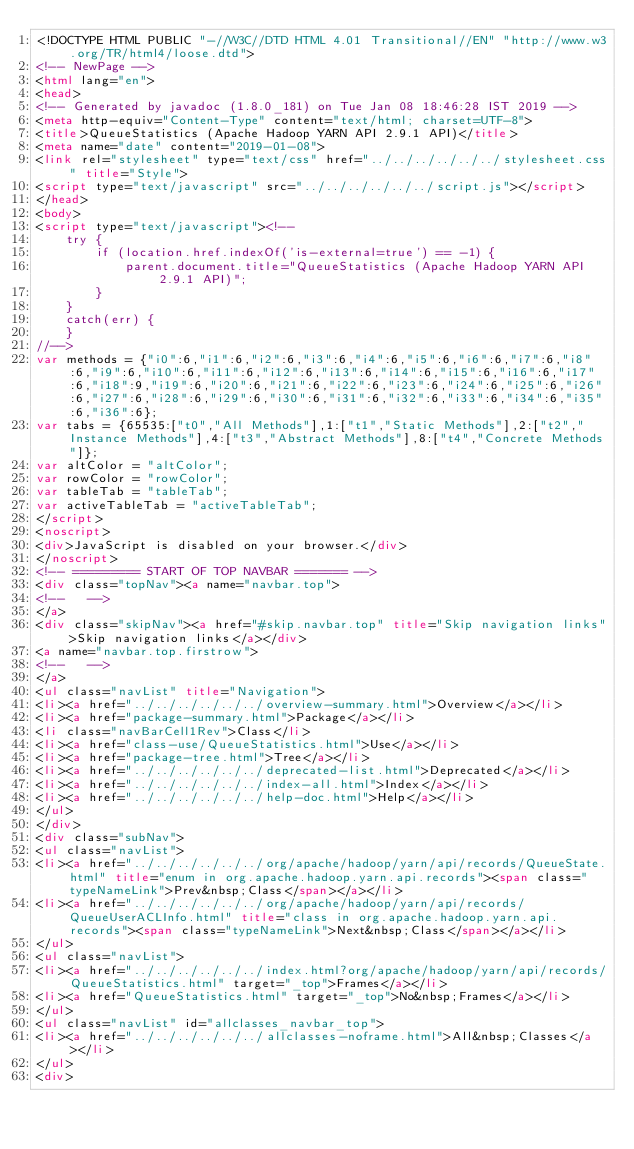Convert code to text. <code><loc_0><loc_0><loc_500><loc_500><_HTML_><!DOCTYPE HTML PUBLIC "-//W3C//DTD HTML 4.01 Transitional//EN" "http://www.w3.org/TR/html4/loose.dtd">
<!-- NewPage -->
<html lang="en">
<head>
<!-- Generated by javadoc (1.8.0_181) on Tue Jan 08 18:46:28 IST 2019 -->
<meta http-equiv="Content-Type" content="text/html; charset=UTF-8">
<title>QueueStatistics (Apache Hadoop YARN API 2.9.1 API)</title>
<meta name="date" content="2019-01-08">
<link rel="stylesheet" type="text/css" href="../../../../../../stylesheet.css" title="Style">
<script type="text/javascript" src="../../../../../../script.js"></script>
</head>
<body>
<script type="text/javascript"><!--
    try {
        if (location.href.indexOf('is-external=true') == -1) {
            parent.document.title="QueueStatistics (Apache Hadoop YARN API 2.9.1 API)";
        }
    }
    catch(err) {
    }
//-->
var methods = {"i0":6,"i1":6,"i2":6,"i3":6,"i4":6,"i5":6,"i6":6,"i7":6,"i8":6,"i9":6,"i10":6,"i11":6,"i12":6,"i13":6,"i14":6,"i15":6,"i16":6,"i17":6,"i18":9,"i19":6,"i20":6,"i21":6,"i22":6,"i23":6,"i24":6,"i25":6,"i26":6,"i27":6,"i28":6,"i29":6,"i30":6,"i31":6,"i32":6,"i33":6,"i34":6,"i35":6,"i36":6};
var tabs = {65535:["t0","All Methods"],1:["t1","Static Methods"],2:["t2","Instance Methods"],4:["t3","Abstract Methods"],8:["t4","Concrete Methods"]};
var altColor = "altColor";
var rowColor = "rowColor";
var tableTab = "tableTab";
var activeTableTab = "activeTableTab";
</script>
<noscript>
<div>JavaScript is disabled on your browser.</div>
</noscript>
<!-- ========= START OF TOP NAVBAR ======= -->
<div class="topNav"><a name="navbar.top">
<!--   -->
</a>
<div class="skipNav"><a href="#skip.navbar.top" title="Skip navigation links">Skip navigation links</a></div>
<a name="navbar.top.firstrow">
<!--   -->
</a>
<ul class="navList" title="Navigation">
<li><a href="../../../../../../overview-summary.html">Overview</a></li>
<li><a href="package-summary.html">Package</a></li>
<li class="navBarCell1Rev">Class</li>
<li><a href="class-use/QueueStatistics.html">Use</a></li>
<li><a href="package-tree.html">Tree</a></li>
<li><a href="../../../../../../deprecated-list.html">Deprecated</a></li>
<li><a href="../../../../../../index-all.html">Index</a></li>
<li><a href="../../../../../../help-doc.html">Help</a></li>
</ul>
</div>
<div class="subNav">
<ul class="navList">
<li><a href="../../../../../../org/apache/hadoop/yarn/api/records/QueueState.html" title="enum in org.apache.hadoop.yarn.api.records"><span class="typeNameLink">Prev&nbsp;Class</span></a></li>
<li><a href="../../../../../../org/apache/hadoop/yarn/api/records/QueueUserACLInfo.html" title="class in org.apache.hadoop.yarn.api.records"><span class="typeNameLink">Next&nbsp;Class</span></a></li>
</ul>
<ul class="navList">
<li><a href="../../../../../../index.html?org/apache/hadoop/yarn/api/records/QueueStatistics.html" target="_top">Frames</a></li>
<li><a href="QueueStatistics.html" target="_top">No&nbsp;Frames</a></li>
</ul>
<ul class="navList" id="allclasses_navbar_top">
<li><a href="../../../../../../allclasses-noframe.html">All&nbsp;Classes</a></li>
</ul>
<div></code> 